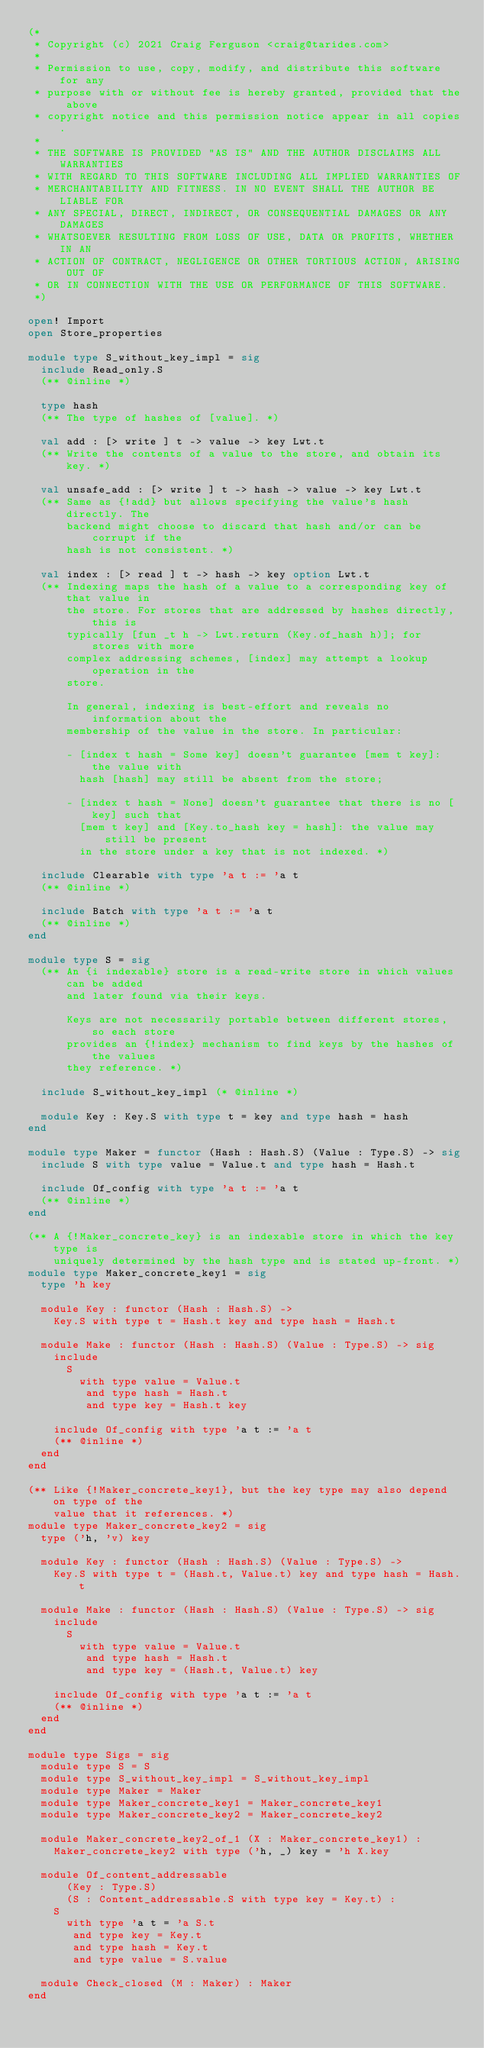Convert code to text. <code><loc_0><loc_0><loc_500><loc_500><_OCaml_>(*
 * Copyright (c) 2021 Craig Ferguson <craig@tarides.com>
 *
 * Permission to use, copy, modify, and distribute this software for any
 * purpose with or without fee is hereby granted, provided that the above
 * copyright notice and this permission notice appear in all copies.
 *
 * THE SOFTWARE IS PROVIDED "AS IS" AND THE AUTHOR DISCLAIMS ALL WARRANTIES
 * WITH REGARD TO THIS SOFTWARE INCLUDING ALL IMPLIED WARRANTIES OF
 * MERCHANTABILITY AND FITNESS. IN NO EVENT SHALL THE AUTHOR BE LIABLE FOR
 * ANY SPECIAL, DIRECT, INDIRECT, OR CONSEQUENTIAL DAMAGES OR ANY DAMAGES
 * WHATSOEVER RESULTING FROM LOSS OF USE, DATA OR PROFITS, WHETHER IN AN
 * ACTION OF CONTRACT, NEGLIGENCE OR OTHER TORTIOUS ACTION, ARISING OUT OF
 * OR IN CONNECTION WITH THE USE OR PERFORMANCE OF THIS SOFTWARE.
 *)

open! Import
open Store_properties

module type S_without_key_impl = sig
  include Read_only.S
  (** @inline *)

  type hash
  (** The type of hashes of [value]. *)

  val add : [> write ] t -> value -> key Lwt.t
  (** Write the contents of a value to the store, and obtain its key. *)

  val unsafe_add : [> write ] t -> hash -> value -> key Lwt.t
  (** Same as {!add} but allows specifying the value's hash directly. The
      backend might choose to discard that hash and/or can be corrupt if the
      hash is not consistent. *)

  val index : [> read ] t -> hash -> key option Lwt.t
  (** Indexing maps the hash of a value to a corresponding key of that value in
      the store. For stores that are addressed by hashes directly, this is
      typically [fun _t h -> Lwt.return (Key.of_hash h)]; for stores with more
      complex addressing schemes, [index] may attempt a lookup operation in the
      store.

      In general, indexing is best-effort and reveals no information about the
      membership of the value in the store. In particular:

      - [index t hash = Some key] doesn't guarantee [mem t key]: the value with
        hash [hash] may still be absent from the store;

      - [index t hash = None] doesn't guarantee that there is no [key] such that
        [mem t key] and [Key.to_hash key = hash]: the value may still be present
        in the store under a key that is not indexed. *)

  include Clearable with type 'a t := 'a t
  (** @inline *)

  include Batch with type 'a t := 'a t
  (** @inline *)
end

module type S = sig
  (** An {i indexable} store is a read-write store in which values can be added
      and later found via their keys.

      Keys are not necessarily portable between different stores, so each store
      provides an {!index} mechanism to find keys by the hashes of the values
      they reference. *)

  include S_without_key_impl (* @inline *)

  module Key : Key.S with type t = key and type hash = hash
end

module type Maker = functor (Hash : Hash.S) (Value : Type.S) -> sig
  include S with type value = Value.t and type hash = Hash.t

  include Of_config with type 'a t := 'a t
  (** @inline *)
end

(** A {!Maker_concrete_key} is an indexable store in which the key type is
    uniquely determined by the hash type and is stated up-front. *)
module type Maker_concrete_key1 = sig
  type 'h key

  module Key : functor (Hash : Hash.S) ->
    Key.S with type t = Hash.t key and type hash = Hash.t

  module Make : functor (Hash : Hash.S) (Value : Type.S) -> sig
    include
      S
        with type value = Value.t
         and type hash = Hash.t
         and type key = Hash.t key

    include Of_config with type 'a t := 'a t
    (** @inline *)
  end
end

(** Like {!Maker_concrete_key1}, but the key type may also depend on type of the
    value that it references. *)
module type Maker_concrete_key2 = sig
  type ('h, 'v) key

  module Key : functor (Hash : Hash.S) (Value : Type.S) ->
    Key.S with type t = (Hash.t, Value.t) key and type hash = Hash.t

  module Make : functor (Hash : Hash.S) (Value : Type.S) -> sig
    include
      S
        with type value = Value.t
         and type hash = Hash.t
         and type key = (Hash.t, Value.t) key

    include Of_config with type 'a t := 'a t
    (** @inline *)
  end
end

module type Sigs = sig
  module type S = S
  module type S_without_key_impl = S_without_key_impl
  module type Maker = Maker
  module type Maker_concrete_key1 = Maker_concrete_key1
  module type Maker_concrete_key2 = Maker_concrete_key2

  module Maker_concrete_key2_of_1 (X : Maker_concrete_key1) :
    Maker_concrete_key2 with type ('h, _) key = 'h X.key

  module Of_content_addressable
      (Key : Type.S)
      (S : Content_addressable.S with type key = Key.t) :
    S
      with type 'a t = 'a S.t
       and type key = Key.t
       and type hash = Key.t
       and type value = S.value

  module Check_closed (M : Maker) : Maker
end
</code> 